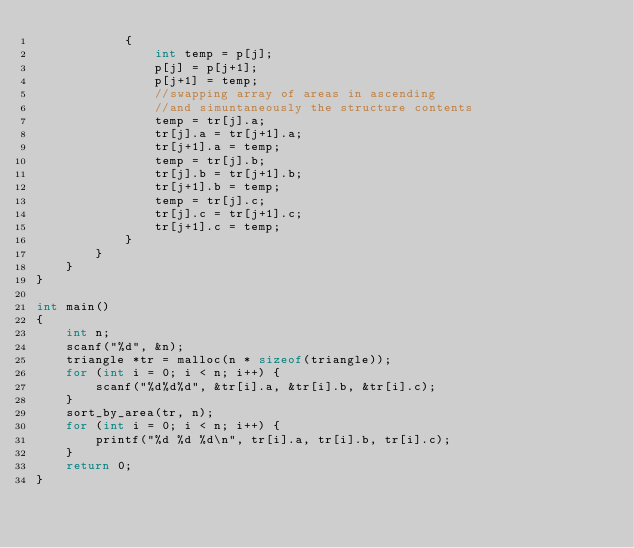Convert code to text. <code><loc_0><loc_0><loc_500><loc_500><_C_>            {
                int temp = p[j];
                p[j] = p[j+1];
                p[j+1] = temp;
                //swapping array of areas in ascending
                //and simuntaneously the structure contents
                temp = tr[j].a;
                tr[j].a = tr[j+1].a;
                tr[j+1].a = temp;
                temp = tr[j].b;
                tr[j].b = tr[j+1].b;
                tr[j+1].b = temp;
                temp = tr[j].c;
                tr[j].c = tr[j+1].c;
                tr[j+1].c = temp;
            }
        }
    }
}

int main()
{
    int n;
    scanf("%d", &n);
    triangle *tr = malloc(n * sizeof(triangle));
    for (int i = 0; i < n; i++) {
        scanf("%d%d%d", &tr[i].a, &tr[i].b, &tr[i].c);
    }
    sort_by_area(tr, n);
    for (int i = 0; i < n; i++) {
        printf("%d %d %d\n", tr[i].a, tr[i].b, tr[i].c);
    }
    return 0;
}</code> 